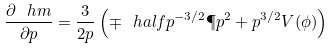Convert formula to latex. <formula><loc_0><loc_0><loc_500><loc_500>\frac { \partial \ h m } { \partial p } = \frac { 3 } { 2 p } \left ( \mp \ h a l f p ^ { - 3 / 2 } \P p ^ { 2 } + p ^ { 3 / 2 } V ( \phi ) \right )</formula> 